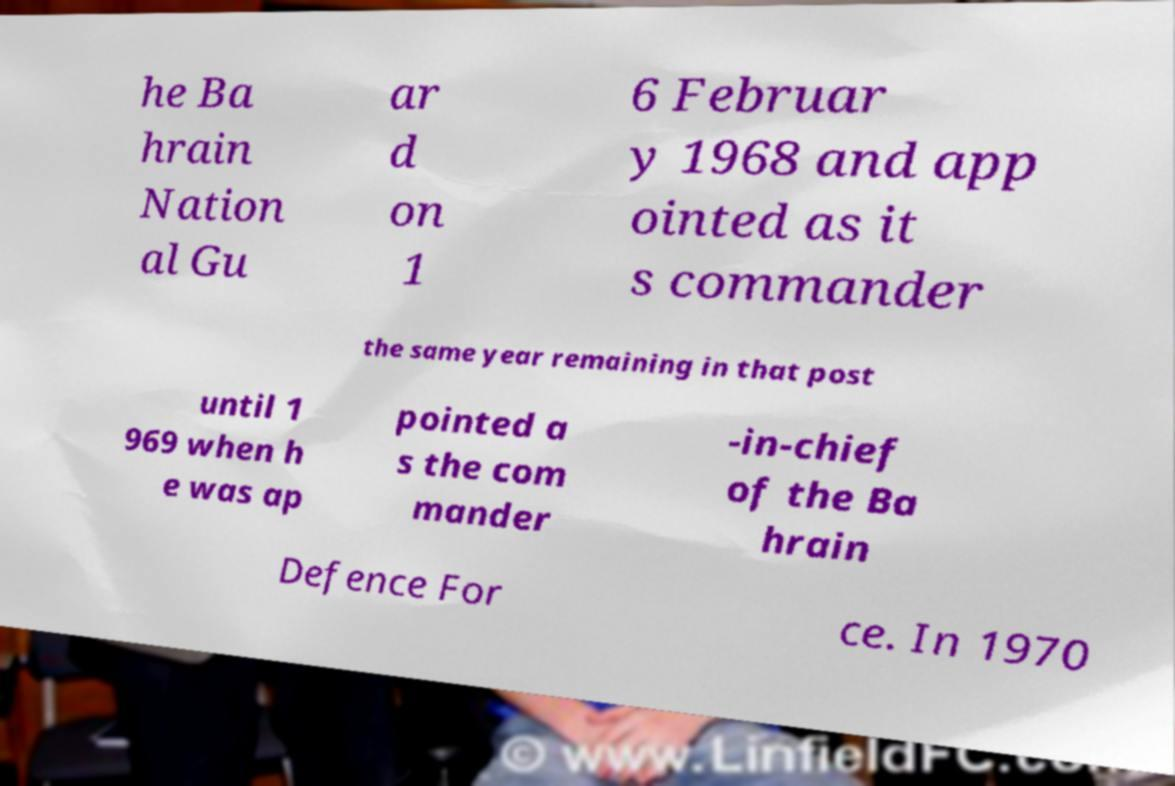Could you extract and type out the text from this image? he Ba hrain Nation al Gu ar d on 1 6 Februar y 1968 and app ointed as it s commander the same year remaining in that post until 1 969 when h e was ap pointed a s the com mander -in-chief of the Ba hrain Defence For ce. In 1970 